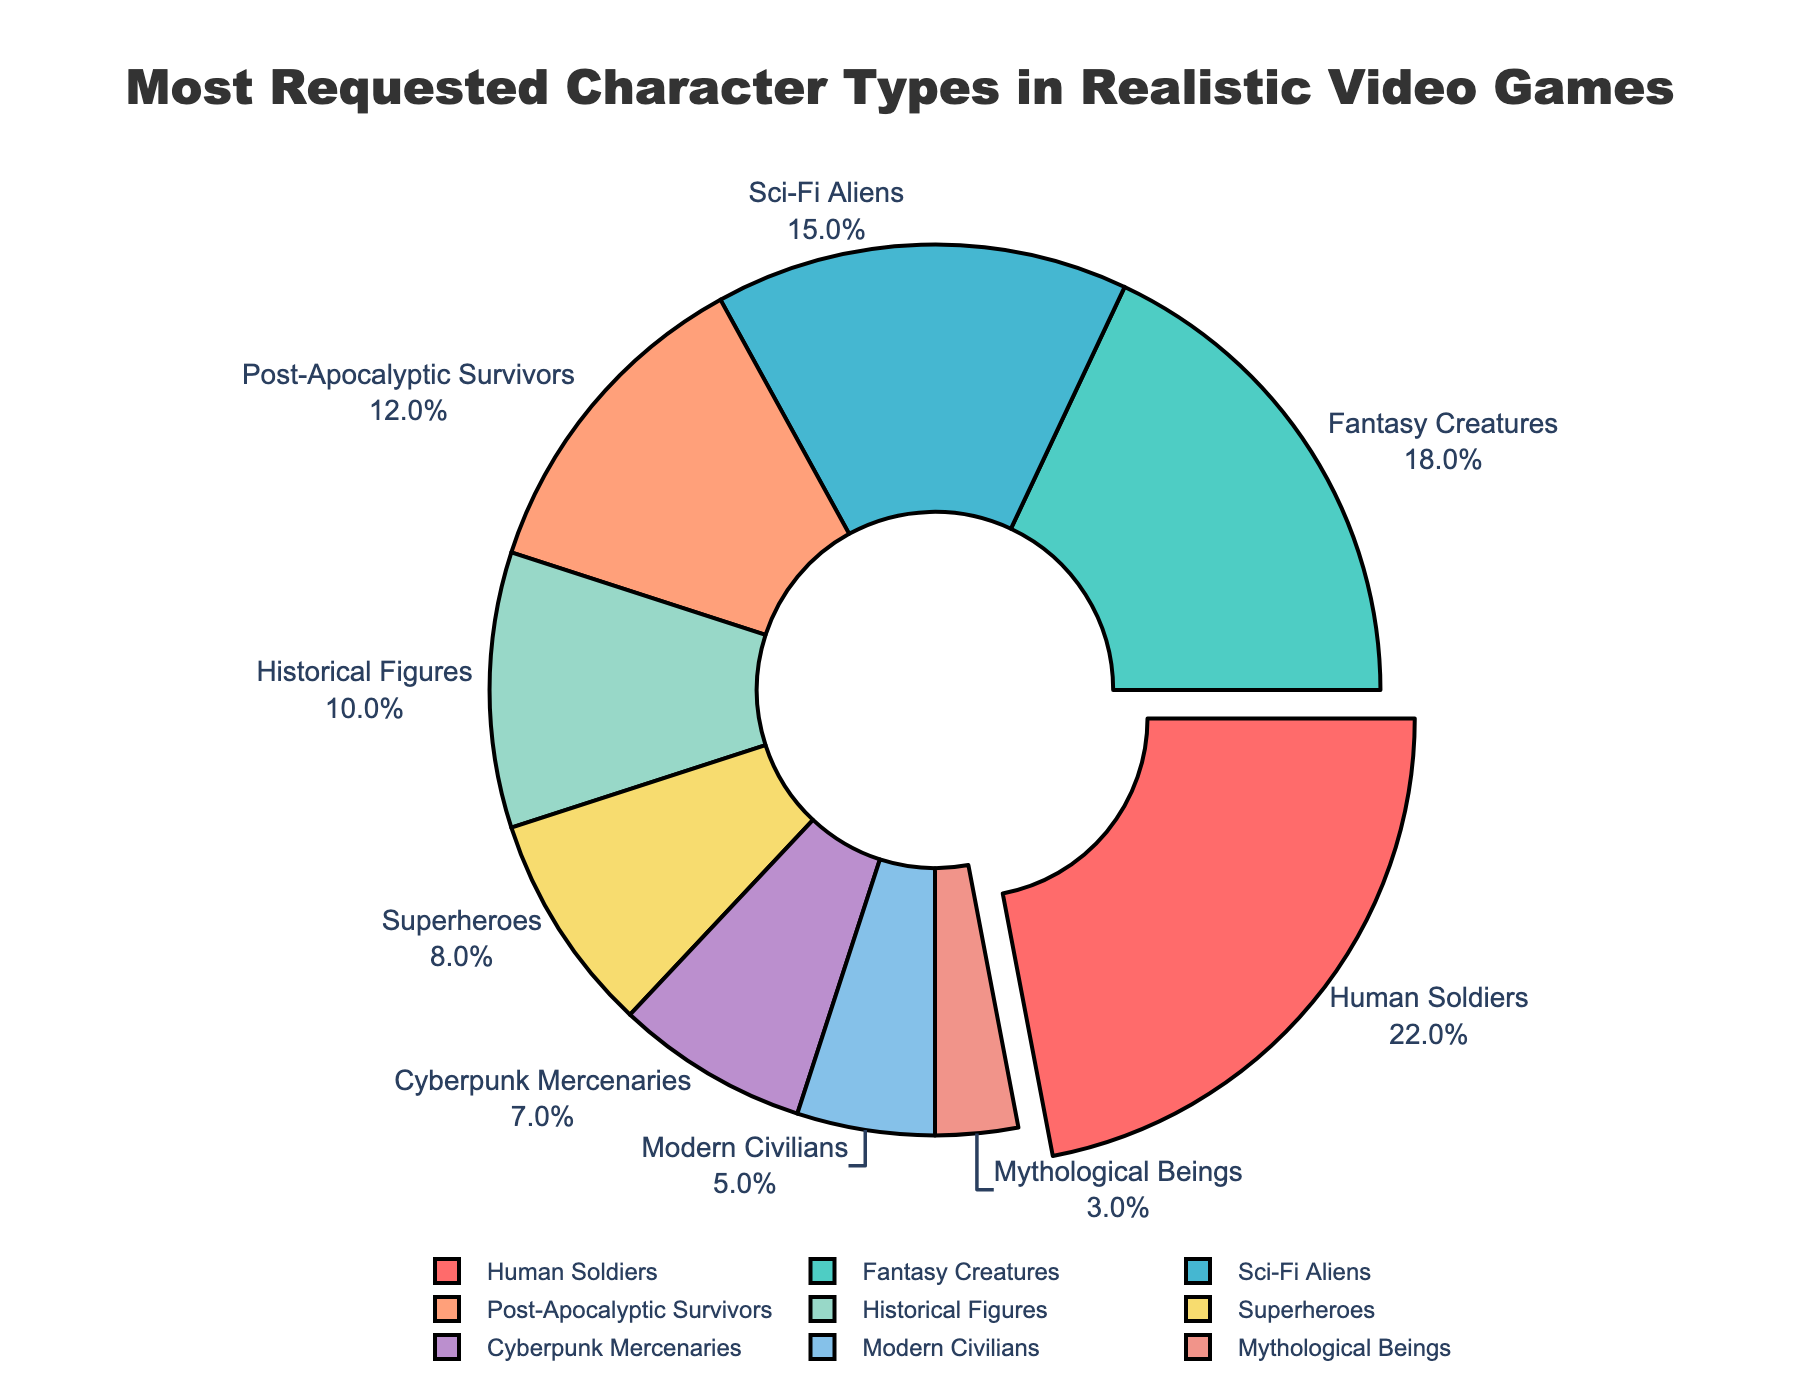What percentage of requested character types are Sci-Fi Aliens and Cyberpunk Mercenaries combined? Add the percentage of Sci-Fi Aliens (15%) to the percentage of Cyberpunk Mercenaries (7%). So, 15% + 7% = 22%.
Answer: 22% Which character type has the highest request percentage? Refer to the chart and identify the character type with the largest percentage value. Human Soldiers have the highest percentage at 22%.
Answer: Human Soldiers Which two character types have the smallest difference in their request percentages? Identify character types with close percentages and calculate the differences. The difference between Superheroes (8%) and Cyberpunk Mercenaries (7%) is 1%, which is the smallest.
Answer: Superheroes and Cyberpunk Mercenaries What is the average percentage of Fantasy Creatures, Sci-Fi Aliens, and Post-Apocalyptic Survivors? Calculate the sum of the percentages of these three types: 18% (Fantasy Creatures) + 15% (Sci-Fi Aliens) + 12% (Post-Apocalyptic Survivors) = 45%. Then divide by 3. So, 45% / 3 = 15%.
Answer: 15% Which character type occupies the red-colored segment of the pie chart? Check the color coding in the chart. The red-colored segment represents Human Soldiers, which has the highest percentage.
Answer: Human Soldiers How much greater is the percentage of Human Soldiers compared to Modern Civilians? Subtract the percentage of Modern Civilians (5%) from the percentage of Human Soldiers (22%). So, 22% - 5% = 17%.
Answer: 17% Are there more requested character types with percentages above or below 10%? Count the number of character types with percentages greater than 10% and compare with those below. There are five (22%, 18%, 15%, 12%, 10%) above and six (8%, 7%, 5%, 3%) below.
Answer: More above What is the combined percentage of the four least requested character types? Add the percentages of the four character types with the lowest values: 8% (Superheroes) + 7% (Cyberpunk Mercenaries) + 5% (Modern Civilians) + 3% (Mythological Beings) = 23%.
Answer: 23% Which character types have a combined total of exactly 30% when added together? Evaluate combinations of character types to see which sum up to 30%. Historical Figures (10%) and Sci-Fi Aliens (15%), and Modern Civilians (5%) combine to make 30%.
Answer: Historical Figures, Sci-Fi Aliens, Modern Civilians 